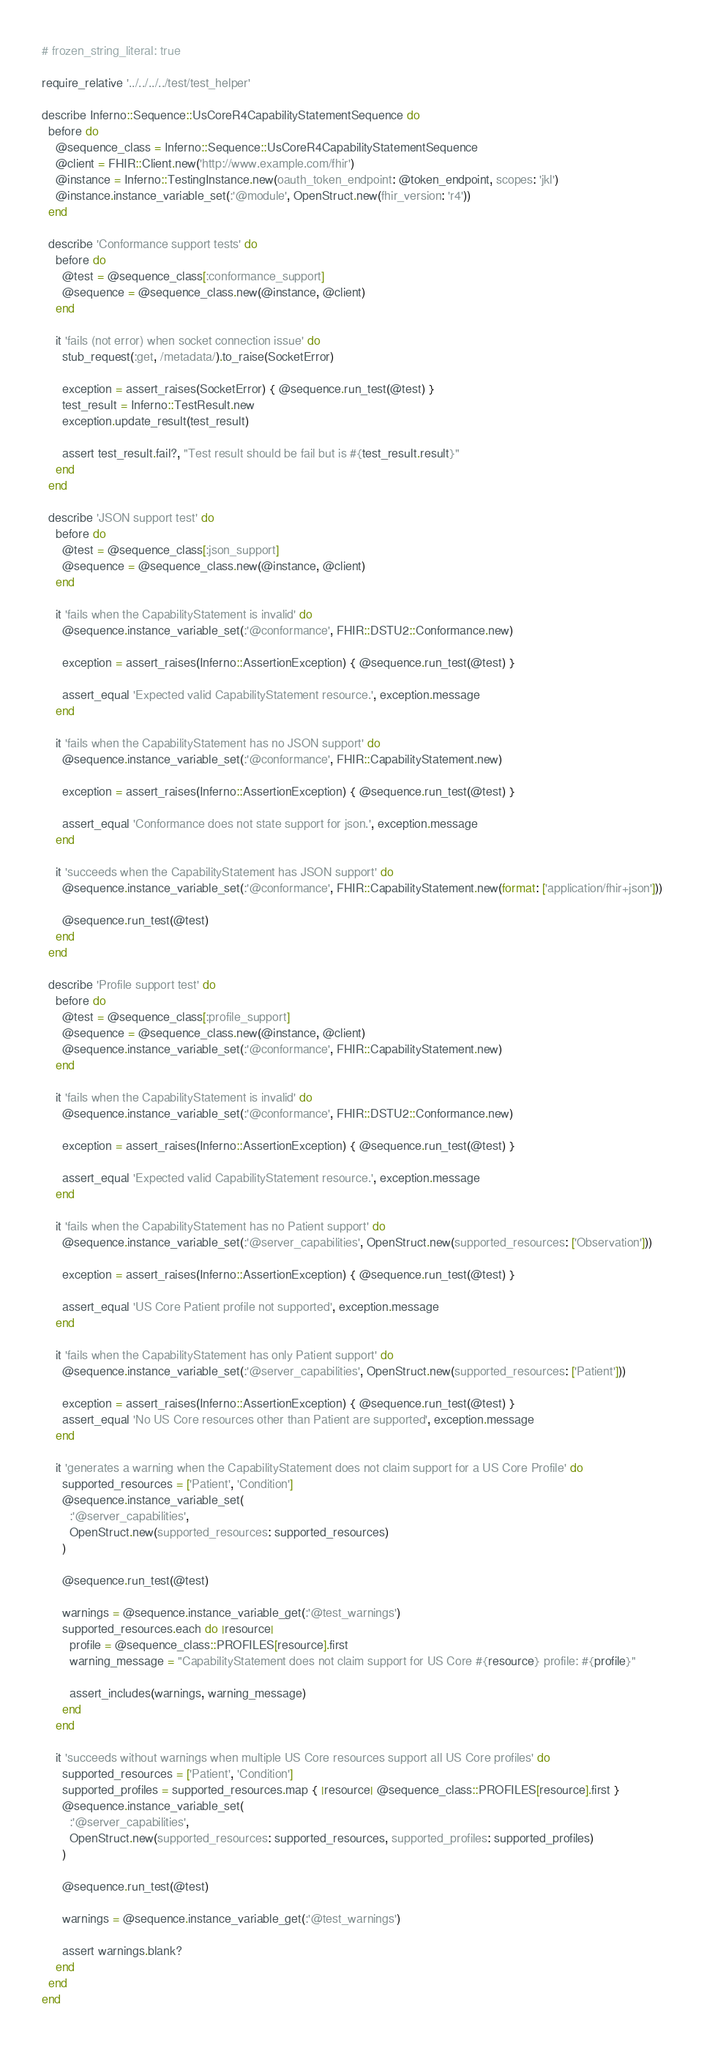<code> <loc_0><loc_0><loc_500><loc_500><_Ruby_># frozen_string_literal: true

require_relative '../../../../test/test_helper'

describe Inferno::Sequence::UsCoreR4CapabilityStatementSequence do
  before do
    @sequence_class = Inferno::Sequence::UsCoreR4CapabilityStatementSequence
    @client = FHIR::Client.new('http://www.example.com/fhir')
    @instance = Inferno::TestingInstance.new(oauth_token_endpoint: @token_endpoint, scopes: 'jkl')
    @instance.instance_variable_set(:'@module', OpenStruct.new(fhir_version: 'r4'))
  end

  describe 'Conformance support tests' do
    before do
      @test = @sequence_class[:conformance_support]
      @sequence = @sequence_class.new(@instance, @client)
    end

    it 'fails (not error) when socket connection issue' do
      stub_request(:get, /metadata/).to_raise(SocketError)

      exception = assert_raises(SocketError) { @sequence.run_test(@test) }
      test_result = Inferno::TestResult.new
      exception.update_result(test_result)

      assert test_result.fail?, "Test result should be fail but is #{test_result.result}"
    end
  end

  describe 'JSON support test' do
    before do
      @test = @sequence_class[:json_support]
      @sequence = @sequence_class.new(@instance, @client)
    end

    it 'fails when the CapabilityStatement is invalid' do
      @sequence.instance_variable_set(:'@conformance', FHIR::DSTU2::Conformance.new)

      exception = assert_raises(Inferno::AssertionException) { @sequence.run_test(@test) }

      assert_equal 'Expected valid CapabilityStatement resource.', exception.message
    end

    it 'fails when the CapabilityStatement has no JSON support' do
      @sequence.instance_variable_set(:'@conformance', FHIR::CapabilityStatement.new)

      exception = assert_raises(Inferno::AssertionException) { @sequence.run_test(@test) }

      assert_equal 'Conformance does not state support for json.', exception.message
    end

    it 'succeeds when the CapabilityStatement has JSON support' do
      @sequence.instance_variable_set(:'@conformance', FHIR::CapabilityStatement.new(format: ['application/fhir+json']))

      @sequence.run_test(@test)
    end
  end

  describe 'Profile support test' do
    before do
      @test = @sequence_class[:profile_support]
      @sequence = @sequence_class.new(@instance, @client)
      @sequence.instance_variable_set(:'@conformance', FHIR::CapabilityStatement.new)
    end

    it 'fails when the CapabilityStatement is invalid' do
      @sequence.instance_variable_set(:'@conformance', FHIR::DSTU2::Conformance.new)

      exception = assert_raises(Inferno::AssertionException) { @sequence.run_test(@test) }

      assert_equal 'Expected valid CapabilityStatement resource.', exception.message
    end

    it 'fails when the CapabilityStatement has no Patient support' do
      @sequence.instance_variable_set(:'@server_capabilities', OpenStruct.new(supported_resources: ['Observation']))

      exception = assert_raises(Inferno::AssertionException) { @sequence.run_test(@test) }

      assert_equal 'US Core Patient profile not supported', exception.message
    end

    it 'fails when the CapabilityStatement has only Patient support' do
      @sequence.instance_variable_set(:'@server_capabilities', OpenStruct.new(supported_resources: ['Patient']))

      exception = assert_raises(Inferno::AssertionException) { @sequence.run_test(@test) }
      assert_equal 'No US Core resources other than Patient are supported', exception.message
    end

    it 'generates a warning when the CapabilityStatement does not claim support for a US Core Profile' do
      supported_resources = ['Patient', 'Condition']
      @sequence.instance_variable_set(
        :'@server_capabilities',
        OpenStruct.new(supported_resources: supported_resources)
      )

      @sequence.run_test(@test)

      warnings = @sequence.instance_variable_get(:'@test_warnings')
      supported_resources.each do |resource|
        profile = @sequence_class::PROFILES[resource].first
        warning_message = "CapabilityStatement does not claim support for US Core #{resource} profile: #{profile}"

        assert_includes(warnings, warning_message)
      end
    end

    it 'succeeds without warnings when multiple US Core resources support all US Core profiles' do
      supported_resources = ['Patient', 'Condition']
      supported_profiles = supported_resources.map { |resource| @sequence_class::PROFILES[resource].first }
      @sequence.instance_variable_set(
        :'@server_capabilities',
        OpenStruct.new(supported_resources: supported_resources, supported_profiles: supported_profiles)
      )

      @sequence.run_test(@test)

      warnings = @sequence.instance_variable_get(:'@test_warnings')

      assert warnings.blank?
    end
  end
end
</code> 